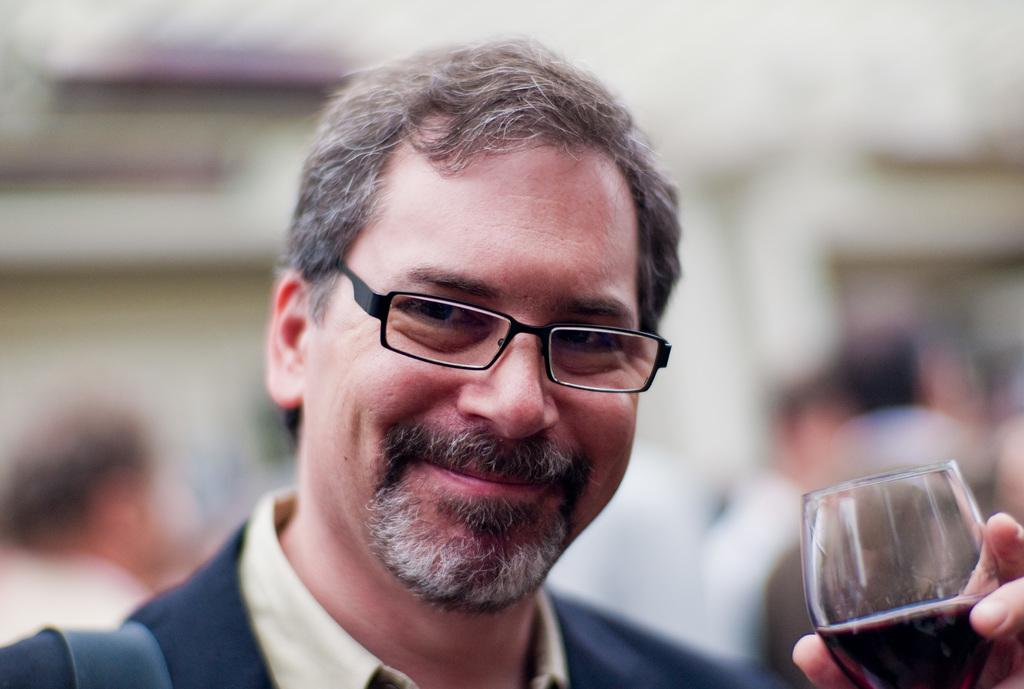Who is present in the image? There is a man in the image. What is the man wearing? The man is wearing a blue shirt. What is the man holding in the image? The man is holding a glass containing some liquid. What accessory is the man wearing? The man is wearing spectacles. What is the man's facial expression in the image? The man is smiling. What type of stitch is the man using to sew the card in the image? There is no card or stitching present in the image; the man is holding a glass containing some liquid. 